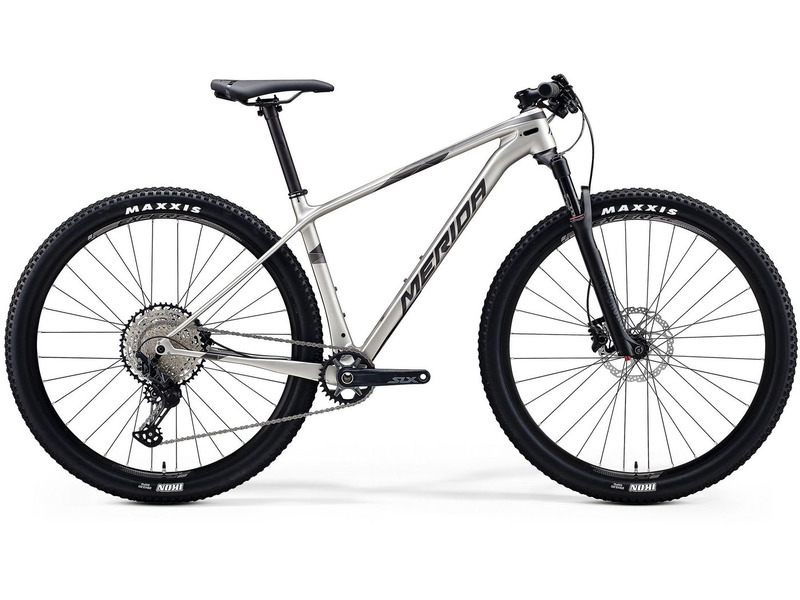If this bike was a character in a fantasy world, what role would it play in an epic quest? In the enchanting world of Eldoria, where mystical forests and towering mountains held ancient secrets, there was a legendary bike known as the 'Silver Steed.' Crafted by the skilled artisans of the mountain dwarfs, the Silver Steed was more than just a bike; it was a trusted companion destined to aid the hero in their epic quest.

Fitted with wheels forged from enchanted metals and wrapped in the toughest dragonhide tread, the Silver Steed possessed unparalleled strength and durability. Its frame, intricately carved with runes of speed and protection, could withstand any terrain, from the rocky passes of the Ironclaw Peaks to the dense, tangled woods of Fangorn Forest.

Our hero, Elara, a courageous rider chosen by fate, discovered the Silver Steed hidden in the depths of an ancient cave, guarded by the spectral guardian, Galen. With Galen's blessing, Elara embarked on a perilous journey to retrieve the Amulet of Everlasting Light, a powerful artifact that could vanquish the growing darkness threatening Eldoria.

Throughout the quest, the Silver Steed showcased its extraordinary abilities. When crossing the perilous deserts of Shimmering Sands, its front suspension absorbed the harsh impacts of the shifting dunes, and the knobby tires gripped the loose sands without faltering. In the treacherous swamps of Murkgloom, the bike’s lightweight and agile build allowed Elara to navigate through the tangled roots and murky waters swiftly.

Through the enchanted forests, the Silver Steed’s silent, smooth ride helped Elara evade detection from magical beasts and hostile sentinels. On the steep, icy peaks of the Frostfang Mountains, its superb traction and stability were crucial in tackling the slippery slopes and dizzying heights.

In the final leg of the journey, as Elara faced the menacing Darklord in his volcanic fortress, the Silver Steed stood unwavering by her side. Its glowing runes, now pulsing with mystical energy, acted as a beacon of hope and strength. With swift maneuvers and resilient fortitude, together they overcame insurmountable obstacles and defeated the Darklord, restoring peace and light to Eldoria.

In the annals of Eldoria’s history, the Silver Steed was forever revered as a legendary companion, a symbol of unwavering strength, and an embodiment of the hero’s spirit and determination. What challenges would the hero face, and how would the bike assist them? In the epic quest of Eldoria, the hero Elara would face numerous challenges, each testing her strength, agility, and wisdom. Here are some of the key challenges and how the Silver Steed would assist her:

1. **The Labyrinth of Shadows**: A complex maze with ever-shifting walls and illusions designed to confuse and trap intruders.
    - The Silver Steed’s runes of insight and direction would illuminate the true path, helping Elara navigate through the labyrinth swiftly and accurately.

2. **The Bridge of the Abyss**: A fragile, ancient bridge stretched over a bottomless chasm, guarded by the ghostly Wraiths of the Shadows that attack any who dare cross.
    - With its lightweight frame and superior agility, the Silver Steed would ensure Elara could make quick, precise movements, dodging attacks and preventing the bridge from collapsing.

3. **The Swamps of Murkgloom**: Treacherous, murky waters filled with deadly creatures and hidden traps.
    - The Silver Steed’s enchanted tires and suspension would provide excellent traction and stability, allowing Elara to maneuver through the swampy terrain without getting bogged down.

4. **The Frostfang Mountains**: Towering, icy peaks riddled with deadly precipices, avalanches, and fierce ice beasts.
    - The bike’s front suspension and knobby tires would absorb shocks and provide grip on the icy slopes, making it possible for Elara to climb and descend the treacherous mountains safely.

5. **The Sea of Whispering Winds**: A vast, magical sea with tempestuous winds and unpredictable waves, requiring a clever and resourceful method to cross.
    - The Silver Steed’s runes of transformation would allow it to morph into a swift glider, enabling Elara to sail above the water safely and swiftly, guided by the winds.

6. **The Darklord's Volcanic Fortress**: The final stronghold of the Darklord, guarded by fiery minions and enchanted barriers.
    - The Silver Steed’s magical enhancements would protect Elara from the intense heat and provide a tactical advantage with its speed and maneuverability, enabling her to outpace and outsmart the Darklord’s minions.

Each challenge would not only test Elara’s physical ability but also her determination and courage. The Silver Steed would serve as a powerful ally throughout her journey, providing the necessary support and capabilities to overcome every obstacle and ultimately triumph in the epic quest. 